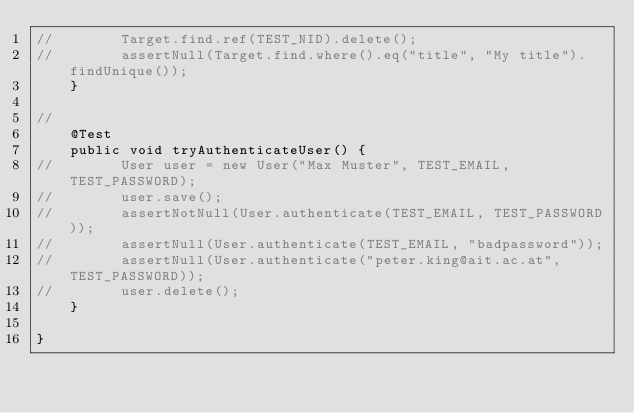Convert code to text. <code><loc_0><loc_0><loc_500><loc_500><_Java_>//        Target.find.ref(TEST_NID).delete();
//        assertNull(Target.find.where().eq("title", "My title").findUnique());
    }

//
    @Test
    public void tryAuthenticateUser() {
//        User user = new User("Max Muster", TEST_EMAIL, TEST_PASSWORD);
//        user.save();
//        assertNotNull(User.authenticate(TEST_EMAIL, TEST_PASSWORD));
//        assertNull(User.authenticate(TEST_EMAIL, "badpassword"));
//        assertNull(User.authenticate("peter.king@ait.ac.at", TEST_PASSWORD));
//        user.delete();
    }
    
}</code> 